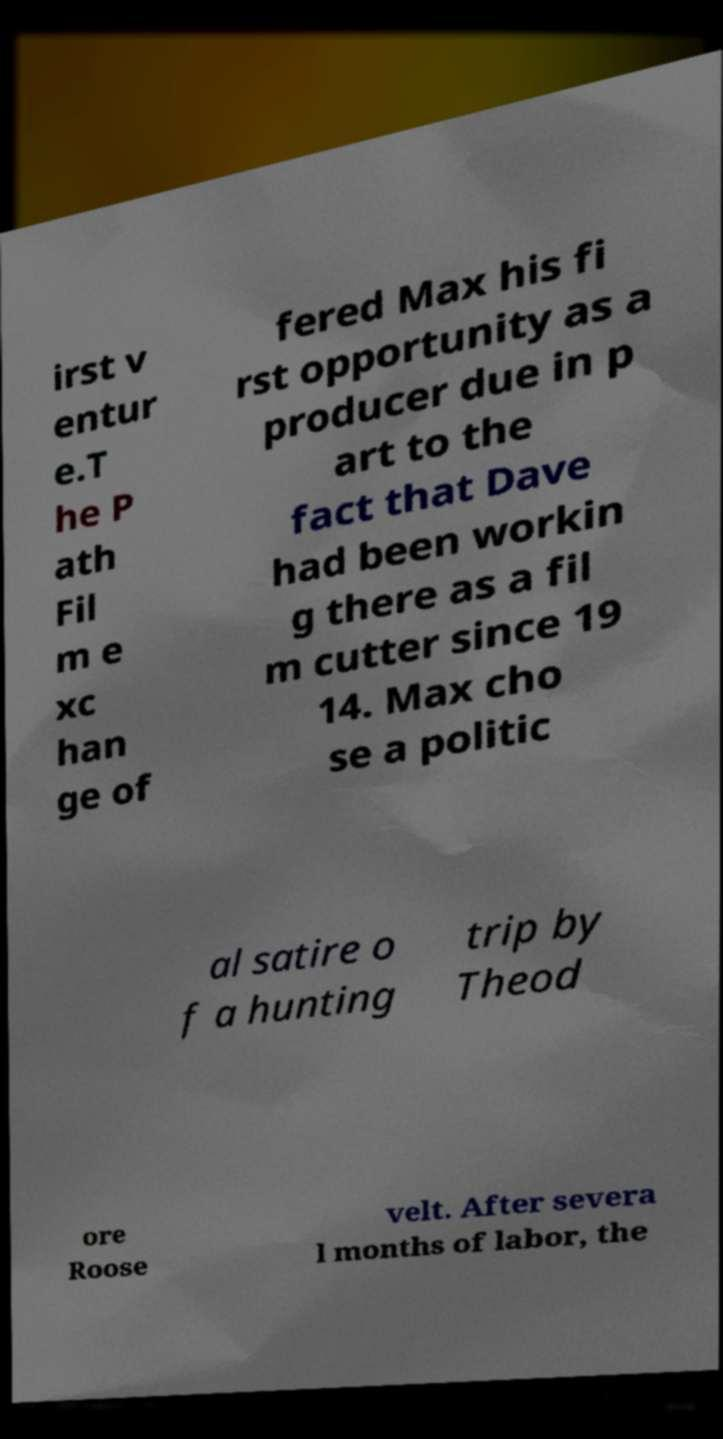Could you extract and type out the text from this image? irst v entur e.T he P ath Fil m e xc han ge of fered Max his fi rst opportunity as a producer due in p art to the fact that Dave had been workin g there as a fil m cutter since 19 14. Max cho se a politic al satire o f a hunting trip by Theod ore Roose velt. After severa l months of labor, the 